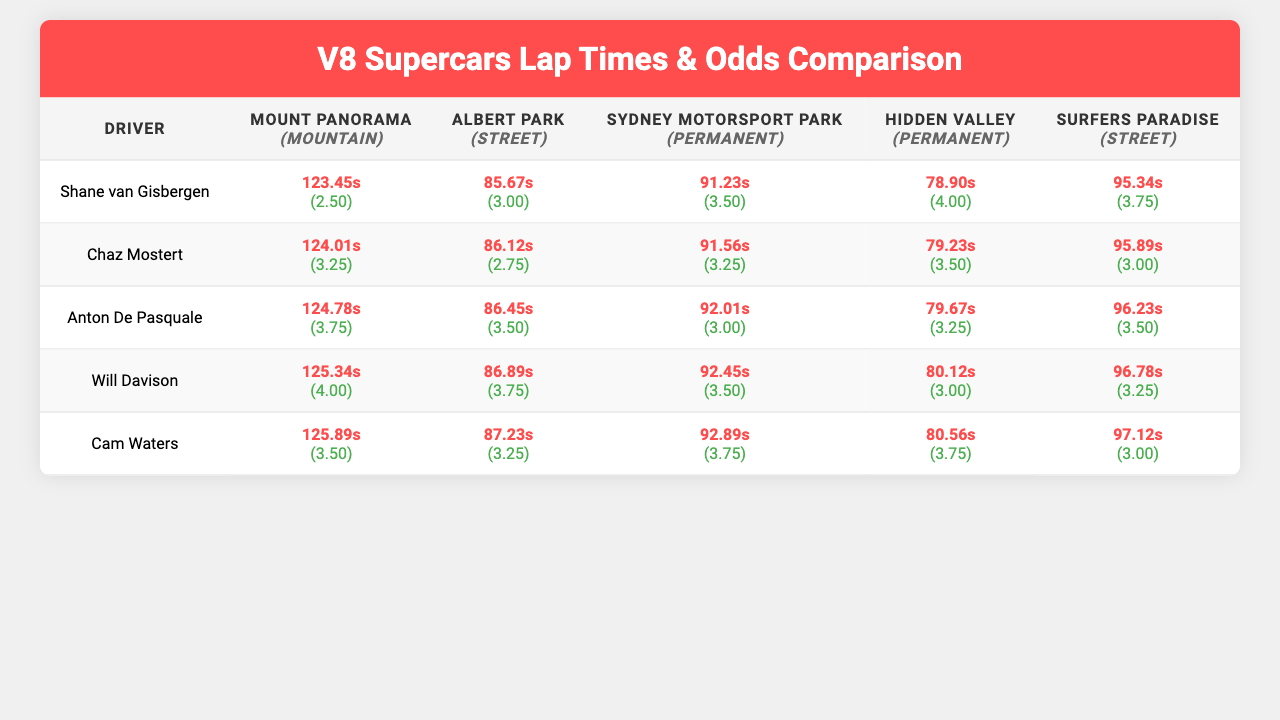What is the fastest lap time recorded by Shane van Gisbergen? Looking at the row for Shane van Gisbergen, the fastest lap time across all tracks is 123.45 seconds, which is listed under Mount Panorama.
Answer: 123.45 seconds Which driver has the slowest lap time on Surfers Paradise? In the Surfers Paradise column, Cam Waters has the slowest lap time of 97.12 seconds.
Answer: Cam Waters What is the average lap time for Chaz Mostert across all track types? The lap times for Chaz Mostert are 124.01, 86.12, 91.56, 79.23, and 95.89 seconds. Summing these gives 124.01 + 86.12 + 91.56 + 79.23 + 95.89 = 476.81 seconds. Dividing by 5 tracks gives an average of 476.81 / 5 = 95.362 seconds.
Answer: 95.36 seconds True or False: Anton De Pasquale has the same lap time on Hidden Valley as on Surfers Paradise. The lap time for Anton De Pasquale on Hidden Valley is 79.67 seconds and on Surfers Paradise is 96.23 seconds. Since these values are not the same, the statement is False.
Answer: False Who is the driver with the lowest odds to win at Mount Panorama? Evaluating the odds for each driver at Mount Panorama, Shane van Gisbergen has the lowest odds at 2.50 for that track.
Answer: Shane van Gisbergen If Chaz Mostert and Cam Waters were to race on Sydney Motorsport Park, what would be the lap time difference between them? The lap time for Chaz Mostert on Sydney Motorsport Park is 86.12 seconds and for Cam Waters is 87.23 seconds. The difference is 87.23 - 86.12 = 1.11 seconds.
Answer: 1.11 seconds Which driver has the fastest lap time on Hidden Valley? On Hidden Valley, Shane van Gisbergen has the fastest lap time of 78.90 seconds when compared to others.
Answer: Shane van Gisbergen If we consider the lap times on Permanent tracks, what is the average lap time for Will Davison? Will Davison's lap times on Permanent tracks (Sydney Motorsport Park and Hidden Valley) are 80.12 seconds and 80.56 seconds. The sum is 80.12 + 80.56 = 160.68 seconds. The average is 160.68 / 2 = 80.34 seconds.
Answer: 80.34 seconds Which driver has the best performance across all tracks based on fastest lap times? Comparing the fastest lap times of all drivers, Shane van Gisbergen has the best overall time of 123.45 seconds at Mount Panorama.
Answer: Shane van Gisbergen Is there a driver that had better lap times on Street tracks than on Permanent tracks? Comparing the lap times for drivers on Street tracks versus Permanent tracks for each driver, Chaz Mostert's street lap time of 86.12 seconds is better than his Permanent lap time of 91.56 seconds. Yes, there is a driver.
Answer: Yes 